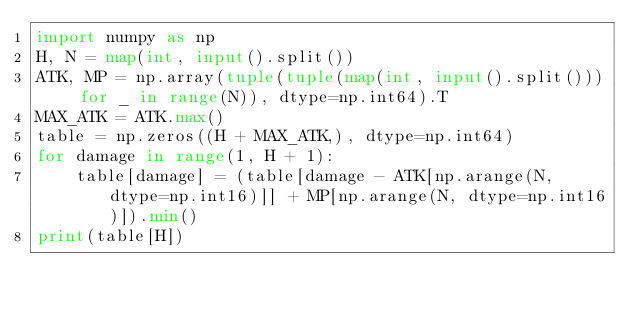Convert code to text. <code><loc_0><loc_0><loc_500><loc_500><_Python_>import numpy as np
H, N = map(int, input().split())
ATK, MP = np.array(tuple(tuple(map(int, input().split())) for _ in range(N)), dtype=np.int64).T
MAX_ATK = ATK.max()
table = np.zeros((H + MAX_ATK,), dtype=np.int64)
for damage in range(1, H + 1):
    table[damage] = (table[damage - ATK[np.arange(N, dtype=np.int16)]] + MP[np.arange(N, dtype=np.int16)]).min()
print(table[H])
</code> 